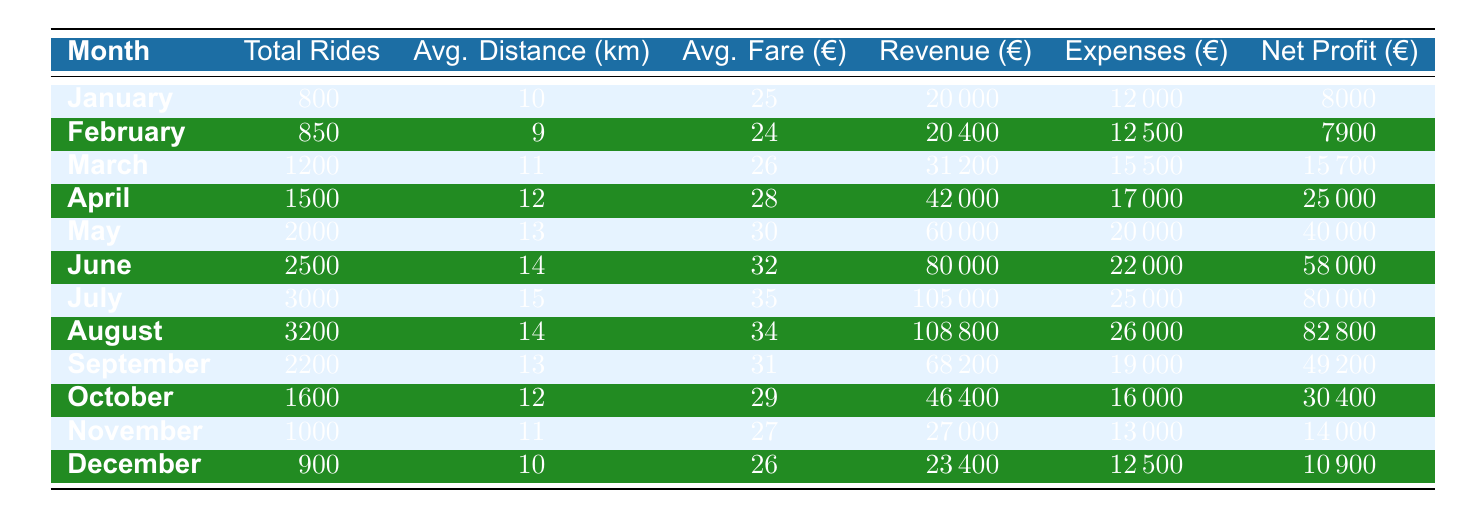What is the total revenue for March? The table indicates that the total revenue for March is listed directly under the "Revenue (€)" column for that month. This value is 31,200 euros.
Answer: 31,200 What were the expenses in July? In the table, to find the expenses for July, we look under the "Expenses (€)" column of that month. The value is 25,000 euros.
Answer: 25,000 Which month had the highest net profit? To determine the month with the highest net profit, we can scan the "Net Profit (€)" column for the maximum value. July shows a net profit of 80,000 euros, which is the highest compared to other months.
Answer: July What is the average fare per ride during the summer months (June, July, August)? We first need the average fares for each of those months: June is 32 euros, July is 35 euros, and August is 34 euros. Next, we calculate the average: (32 + 35 + 34) / 3 = 33.67 euros.
Answer: 33.67 Did the total rides exceed 2000 in May? We check the "Total Rides" column for May, which shows 2000 rides. Since the question asks if it exceeded 2000, we compare: 2000 does not exceed 2000; therefore, the answer is no.
Answer: No Which month had the lowest total rides? To find the month with the lowest total rides, we look at the "Total Rides" column. January has the lowest total at 800 rides compared to other months.
Answer: January What was the net profit for the month with the highest total rides? The table shows July has the highest total rides at 3000. To find its net profit, we check under the "Net Profit (€)" column, which states it is 80,000 euros.
Answer: 80,000 How much more revenue was earned in August than in December? First, we find the revenue for both months: August is 108,800 euros, and December is 23,400 euros. The difference is 108,800 - 23,400 = 85,400 euros.
Answer: 85,400 What is the average ride distance for the year? The average ride distance calculation involves summing all ride distances and dividing by the total number of months. Summing gives (10 + 9 + 11 + 12 + 13 + 14 + 15 + 14 + 13 + 12 + 11 + 10) =  143 km. Dividing by 12 months gives 143 / 12 = 11.92 km.
Answer: 11.92 